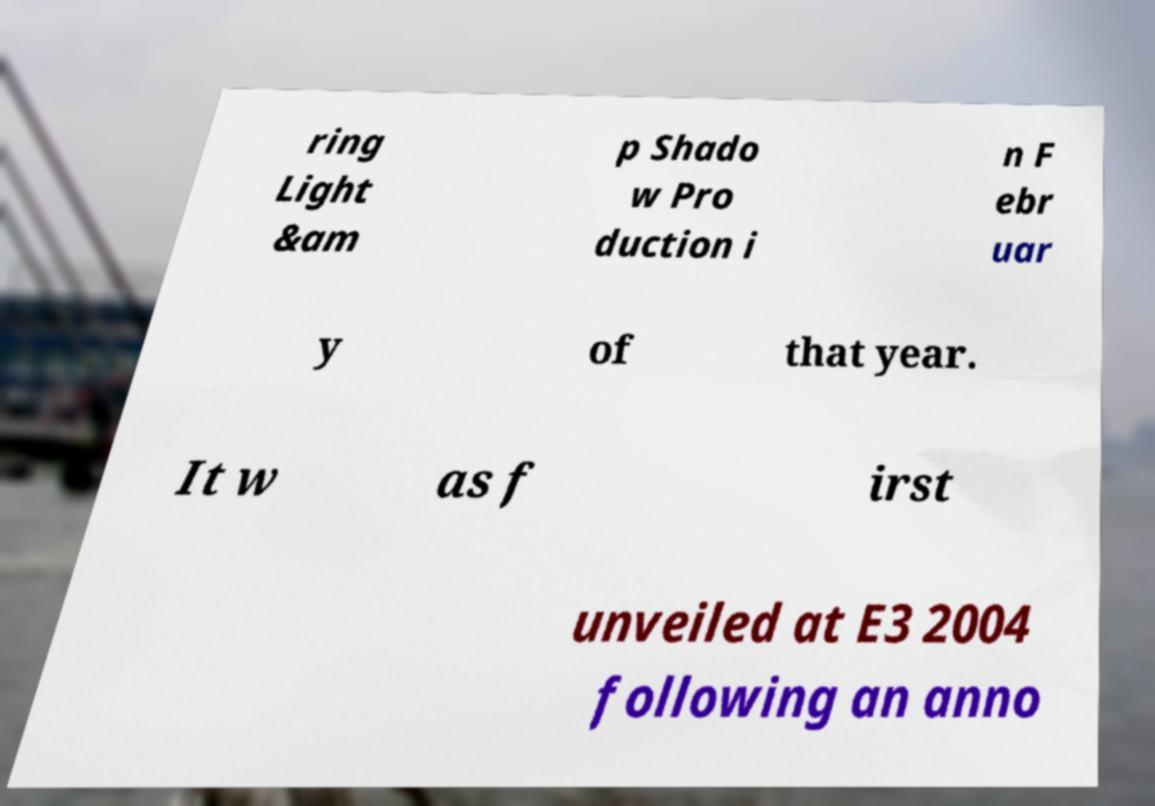Can you read and provide the text displayed in the image?This photo seems to have some interesting text. Can you extract and type it out for me? ring Light &am p Shado w Pro duction i n F ebr uar y of that year. It w as f irst unveiled at E3 2004 following an anno 